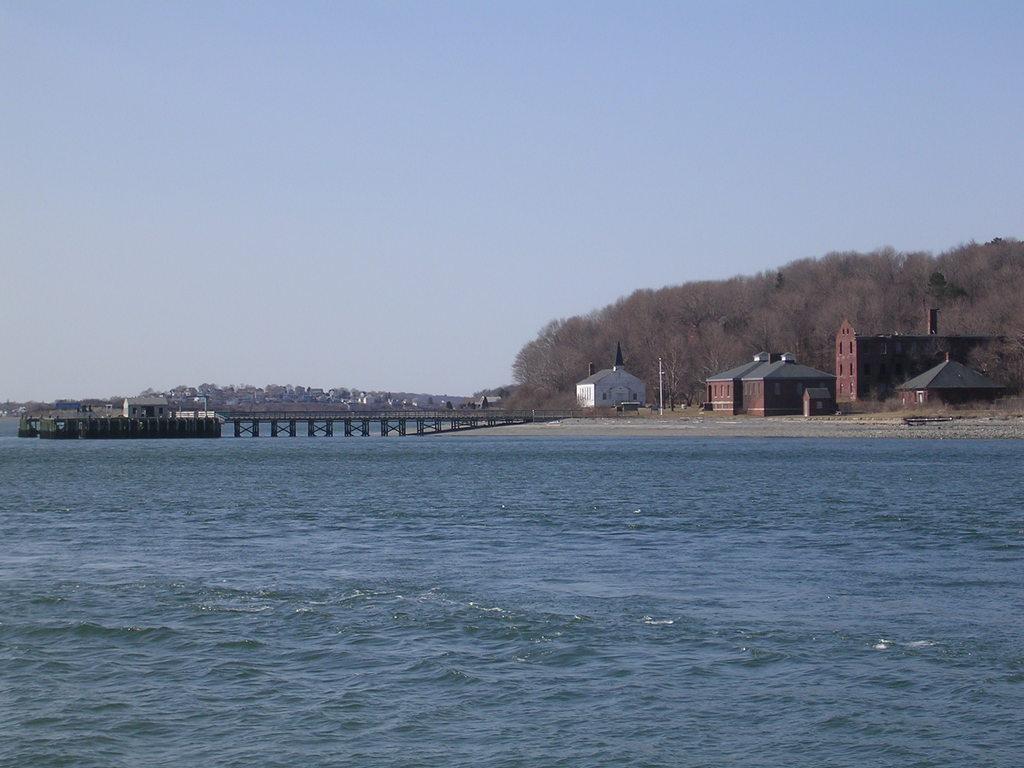How would you summarize this image in a sentence or two? In this picture I can see the water in front and in the middle of this picture I see a bridge, number of buildings and the trees. In the background I see the sky. 